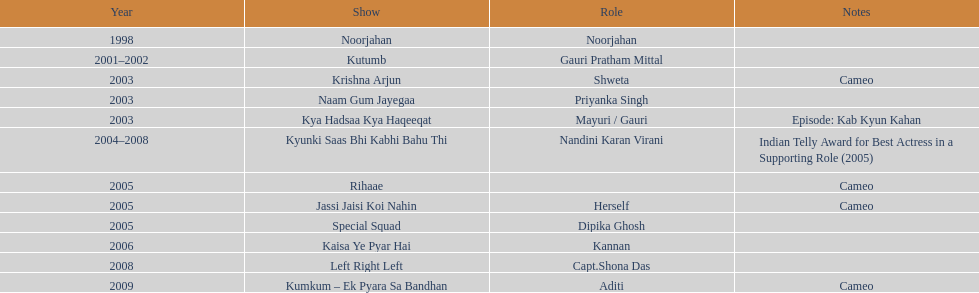What is the maximum number of years a show has run? 4. 